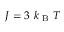<formula> <loc_0><loc_0><loc_500><loc_500>J = 3 k _ { B } T</formula> 